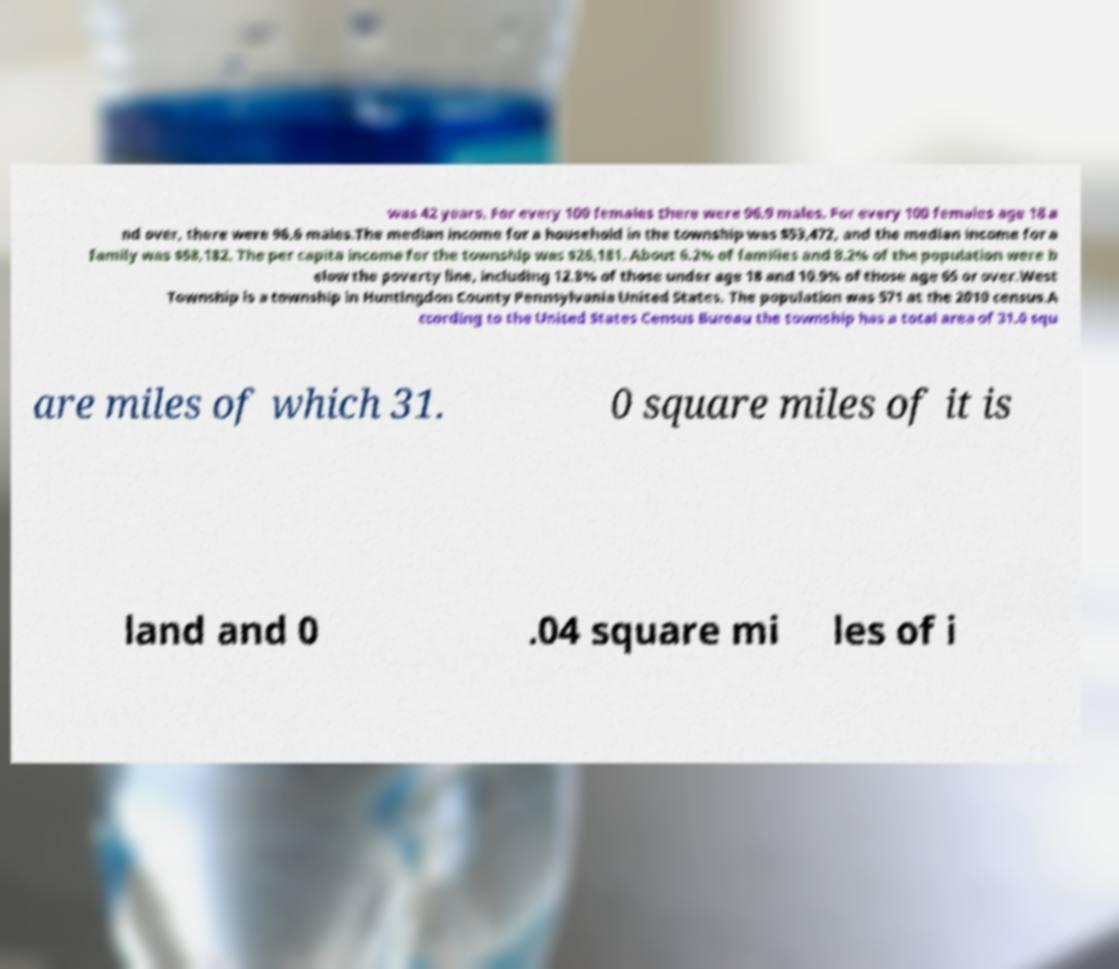Can you read and provide the text displayed in the image?This photo seems to have some interesting text. Can you extract and type it out for me? was 42 years. For every 100 females there were 96.9 males. For every 100 females age 18 a nd over, there were 96.6 males.The median income for a household in the township was $53,472, and the median income for a family was $58,182. The per capita income for the township was $26,181. About 6.2% of families and 8.2% of the population were b elow the poverty line, including 12.8% of those under age 18 and 10.9% of those age 65 or over.West Township is a township in Huntingdon County Pennsylvania United States. The population was 571 at the 2010 census.A ccording to the United States Census Bureau the township has a total area of 31.0 squ are miles of which 31. 0 square miles of it is land and 0 .04 square mi les of i 